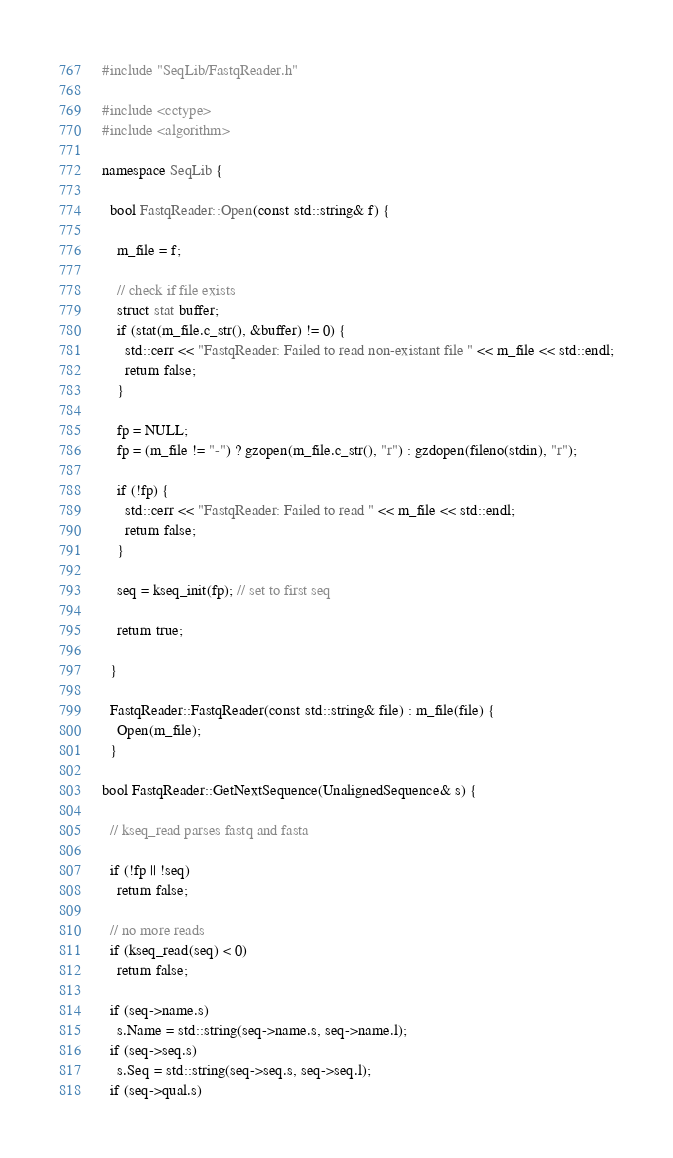<code> <loc_0><loc_0><loc_500><loc_500><_C++_>#include "SeqLib/FastqReader.h"

#include <cctype>
#include <algorithm>

namespace SeqLib {

  bool FastqReader::Open(const std::string& f) {
    
    m_file = f;

    // check if file exists
    struct stat buffer;   
    if (stat(m_file.c_str(), &buffer) != 0) {
      std::cerr << "FastqReader: Failed to read non-existant file " << m_file << std::endl;
      return false;
    }

    fp = NULL;
    fp = (m_file != "-") ? gzopen(m_file.c_str(), "r") : gzdopen(fileno(stdin), "r");

    if (!fp) {
      std::cerr << "FastqReader: Failed to read " << m_file << std::endl;
      return false;
    }

    seq = kseq_init(fp); // set to first seq

    return true;
    
  }

  FastqReader::FastqReader(const std::string& file) : m_file(file) {
    Open(m_file);
  }

bool FastqReader::GetNextSequence(UnalignedSequence& s) {

  // kseq_read parses fastq and fasta

  if (!fp || !seq)
    return false;

  // no more reads
  if (kseq_read(seq) < 0)
    return false;

  if (seq->name.s)
    s.Name = std::string(seq->name.s, seq->name.l);
  if (seq->seq.s)
    s.Seq = std::string(seq->seq.s, seq->seq.l);
  if (seq->qual.s)</code> 